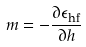Convert formula to latex. <formula><loc_0><loc_0><loc_500><loc_500>m = - \frac { \partial \epsilon _ { \text {hf} } } { \partial h }</formula> 